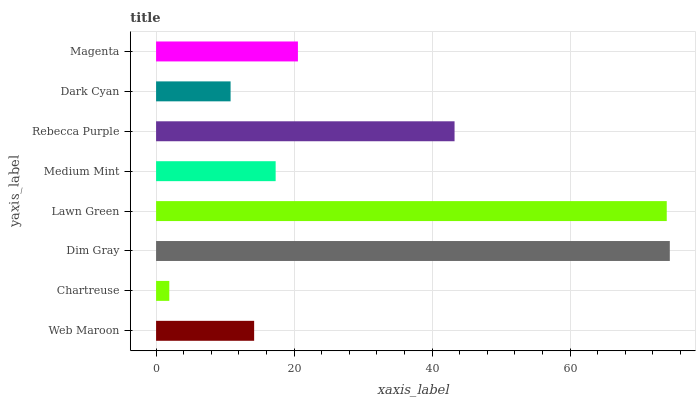Is Chartreuse the minimum?
Answer yes or no. Yes. Is Dim Gray the maximum?
Answer yes or no. Yes. Is Dim Gray the minimum?
Answer yes or no. No. Is Chartreuse the maximum?
Answer yes or no. No. Is Dim Gray greater than Chartreuse?
Answer yes or no. Yes. Is Chartreuse less than Dim Gray?
Answer yes or no. Yes. Is Chartreuse greater than Dim Gray?
Answer yes or no. No. Is Dim Gray less than Chartreuse?
Answer yes or no. No. Is Magenta the high median?
Answer yes or no. Yes. Is Medium Mint the low median?
Answer yes or no. Yes. Is Dim Gray the high median?
Answer yes or no. No. Is Rebecca Purple the low median?
Answer yes or no. No. 